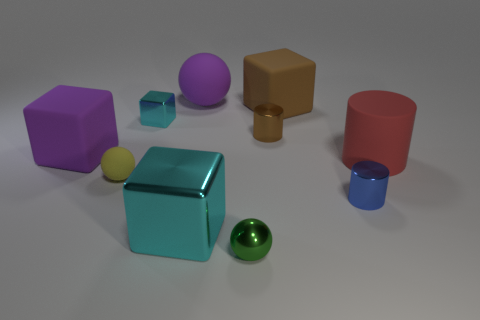There is a yellow ball that is the same size as the brown metal object; what material is it? Given the image, the yellow ball appears to be made of a matte material, consistent with either a rubber or a plastic composition. It's difficult to determine the exact material just by looking, but rubber is a common material for balls of this sort due to its elasticity and grip. 